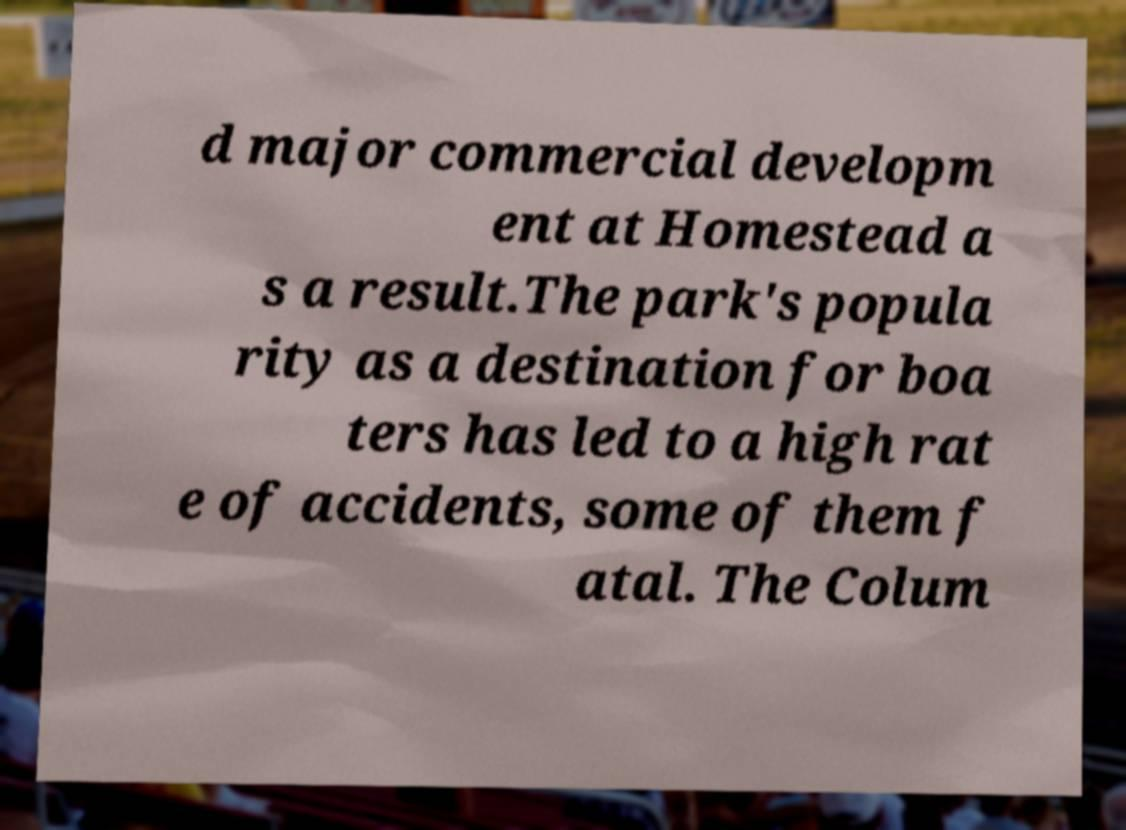Please read and relay the text visible in this image. What does it say? d major commercial developm ent at Homestead a s a result.The park's popula rity as a destination for boa ters has led to a high rat e of accidents, some of them f atal. The Colum 